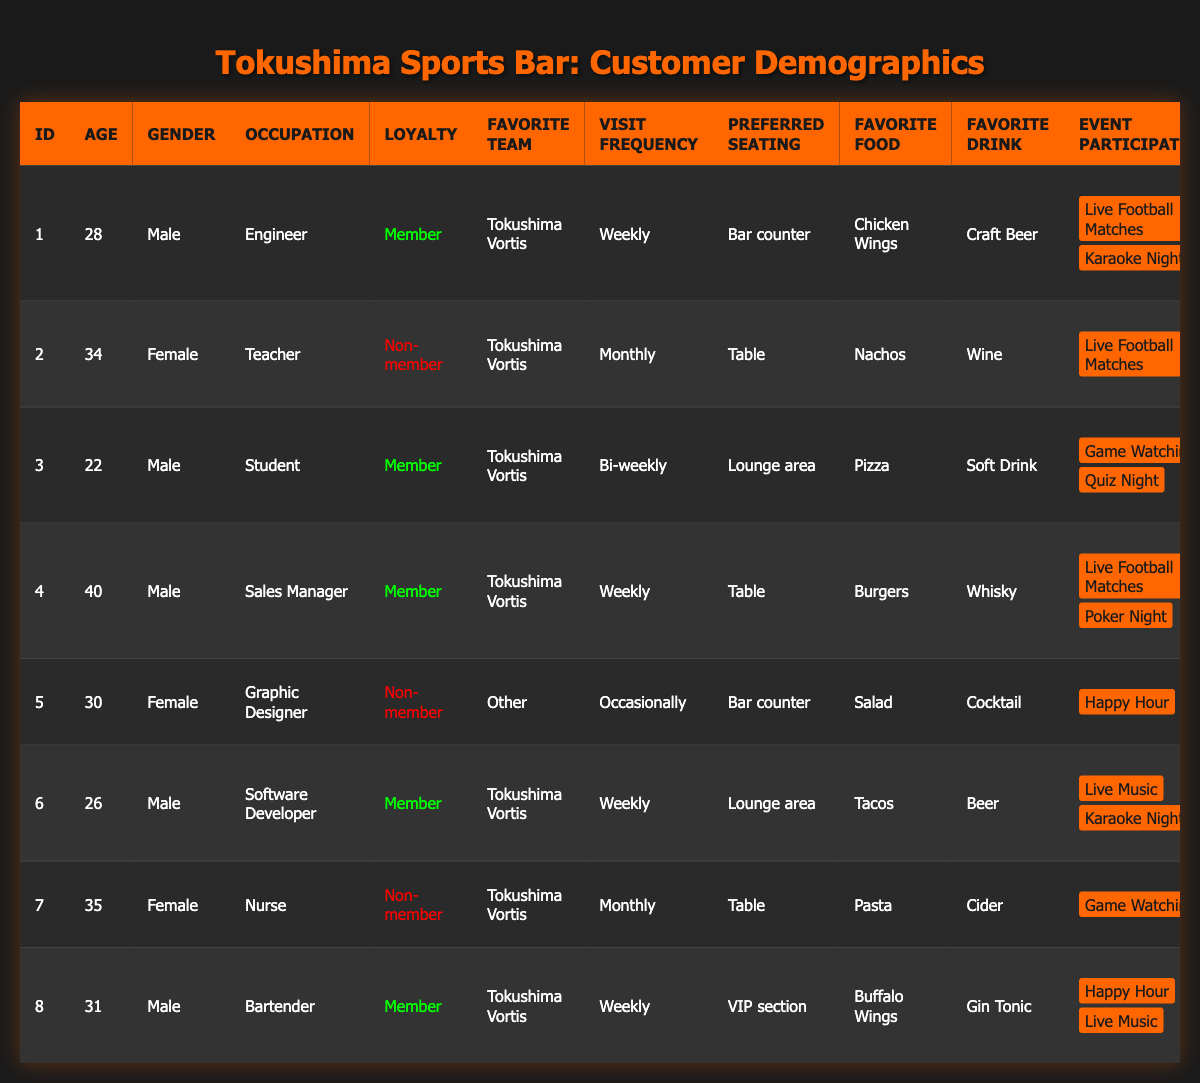What is the favorite food of the customer ID 4? Referring to the table, customer ID 4's favorite food is listed under the "Favorite Food" column, which states "Burgers."
Answer: Burgers How often does customer ID 6 visit the sports bar? In the table, the visit frequency for customer ID 6 is indicated in the "Visit Frequency" column, showing "Weekly."
Answer: Weekly Is customer ID 2 a loyalty member? Looking at the "Loyalty" column for customer ID 2, it clearly indicates "Non-member."
Answer: No How many customers in the table prefer "Table" seating? By counting the entries in the "Preferred Seating" column for "Table," we can see that there are 3 customers (IDs 2, 4, and 7).
Answer: 3 What is the favorite drink for the customer with the favorite food "Pizza"? In the table, we can locate the customer who has "Pizza" listed as their favorite food, which corresponds to customer ID 3, whose favorite drink is "Soft Drink."
Answer: Soft Drink How many female customers are there in total? By reviewing the "Gender" column in the table, we find that there are 4 female customers (IDs 2, 5, 7).
Answer: 4 What is the average age of all customers in the table? The ages from the table are 28, 34, 22, 40, 30, 26, 35, and 31. The sum of these ages is 28 + 34 + 22 + 40 + 30 + 26 + 35 + 31 = 306. There are 8 customers, so the average age is 306/8 = 38.25.
Answer: 38.25 Which favorite team is most commonly mentioned in the table? By examining the "Favorite Team" column, we see that "Tokushima Vortis" appears 6 times compared to "Other" which appears once for customer ID 5.
Answer: Tokushima Vortis What percentage of customers are loyalty members? There are 5 loyalty members (IDs 1, 3, 4, 6, 8) out of 8 total customers. The percentage is calculated as (5/8) * 100 = 62.5%.
Answer: 62.5% How many customers participate in "Live Football Matches" events? By checking the "Event Participation," we find that customers with IDs 1, 2, 4, 6, 7, and 8 all participate in "Live Football Matches." This totals 5 customers.
Answer: 5 